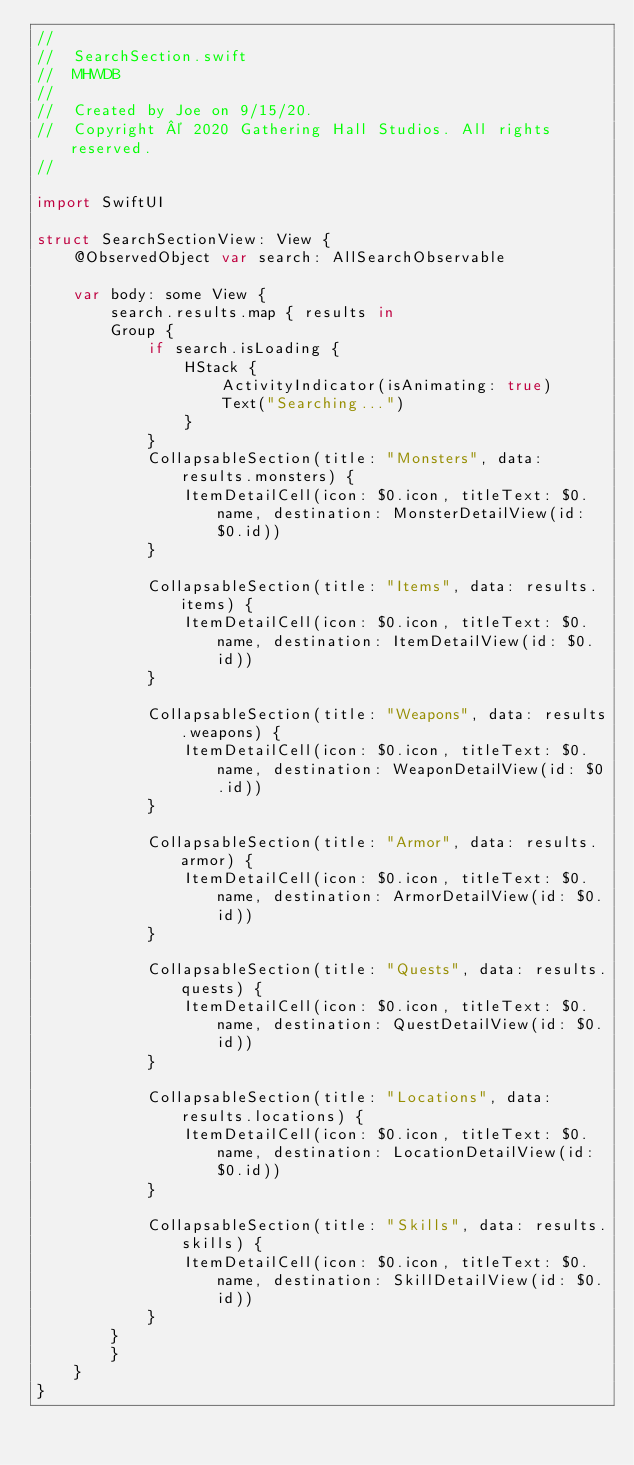<code> <loc_0><loc_0><loc_500><loc_500><_Swift_>//
//  SearchSection.swift
//  MHWDB
//
//  Created by Joe on 9/15/20.
//  Copyright © 2020 Gathering Hall Studios. All rights reserved.
//

import SwiftUI

struct SearchSectionView: View {
    @ObservedObject var search: AllSearchObservable

    var body: some View {
        search.results.map { results in
        Group {
            if search.isLoading {
                HStack {
                    ActivityIndicator(isAnimating: true)
                    Text("Searching...")
                }
            }
            CollapsableSection(title: "Monsters", data: results.monsters) {
                ItemDetailCell(icon: $0.icon, titleText: $0.name, destination: MonsterDetailView(id: $0.id))
            }

            CollapsableSection(title: "Items", data: results.items) {
                ItemDetailCell(icon: $0.icon, titleText: $0.name, destination: ItemDetailView(id: $0.id))
            }

            CollapsableSection(title: "Weapons", data: results.weapons) {
                ItemDetailCell(icon: $0.icon, titleText: $0.name, destination: WeaponDetailView(id: $0.id))
            }

            CollapsableSection(title: "Armor", data: results.armor) {
                ItemDetailCell(icon: $0.icon, titleText: $0.name, destination: ArmorDetailView(id: $0.id))
            }

            CollapsableSection(title: "Quests", data: results.quests) {
                ItemDetailCell(icon: $0.icon, titleText: $0.name, destination: QuestDetailView(id: $0.id))
            }

            CollapsableSection(title: "Locations", data: results.locations) {
                ItemDetailCell(icon: $0.icon, titleText: $0.name, destination: LocationDetailView(id: $0.id))
            }

            CollapsableSection(title: "Skills", data: results.skills) {
                ItemDetailCell(icon: $0.icon, titleText: $0.name, destination: SkillDetailView(id: $0.id))
            }
        }
        }
    }
}
</code> 